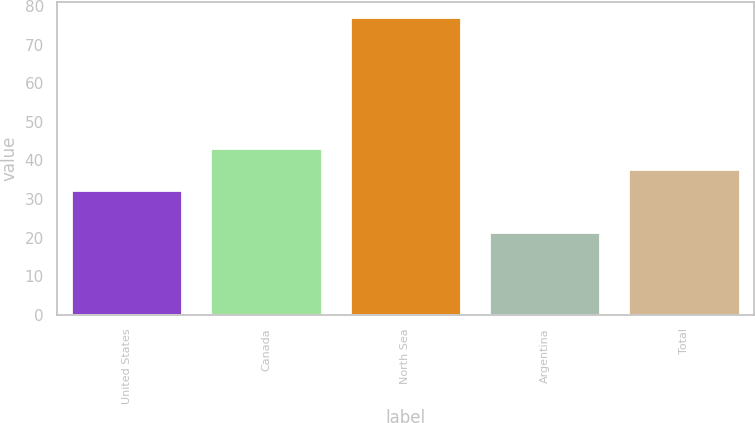Convert chart. <chart><loc_0><loc_0><loc_500><loc_500><bar_chart><fcel>United States<fcel>Canada<fcel>North Sea<fcel>Argentina<fcel>Total<nl><fcel>32.19<fcel>43.31<fcel>77.11<fcel>21.55<fcel>37.75<nl></chart> 